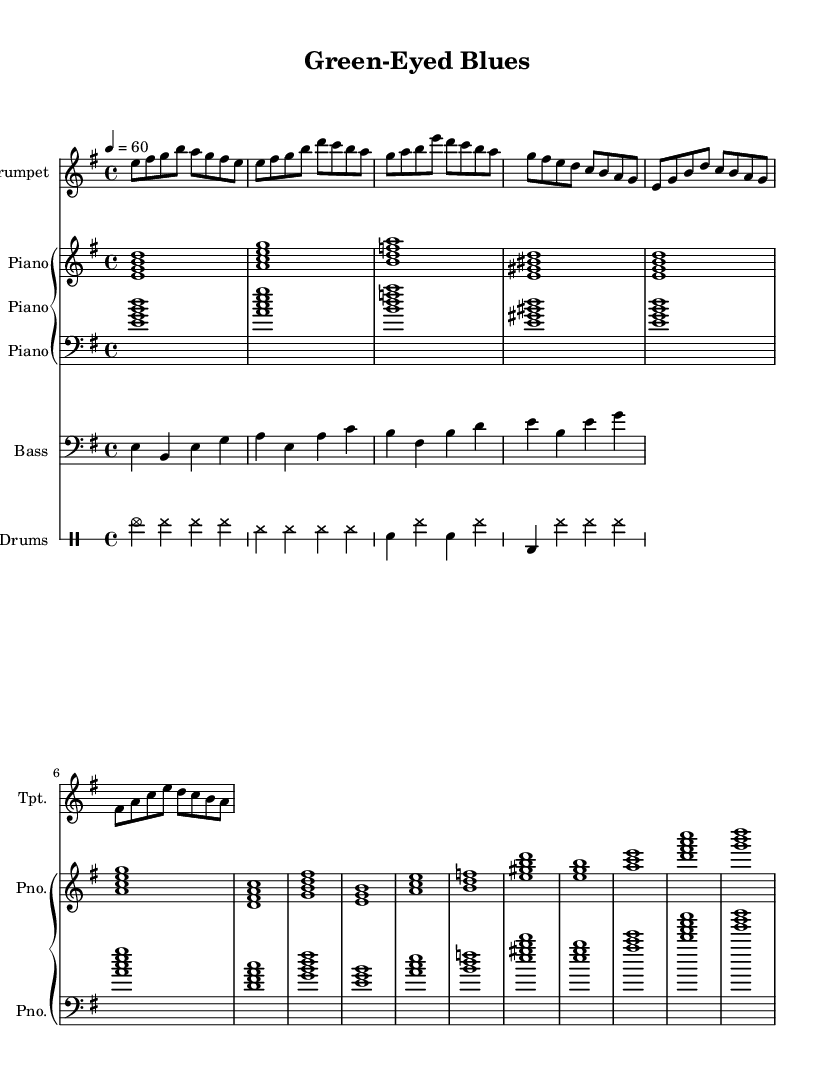What is the key signature of this music? The key signature indicated is E minor, which has one sharp (F#). This can be determined from the initial part of the sheet music where E minor is explicitly stated.
Answer: E minor What is the time signature of this music? The time signature shown in the sheet music is 4/4, which is specified at the beginning of the score. This means there are four beats per measure, and each beat is a quarter note.
Answer: 4/4 What is the tempo marking of this music? The tempo marking is set to 60 beats per minute, as noted in the tempo indication at the start of the score. This indicates a slow pace suitable for smooth jazz.
Answer: 60 Which instruments are included in this piece? The instruments listed are Trumpet, Piano, Bass, and Drums. This is evident from the staff headings in the score that label each instrument accordingly.
Answer: Trumpet, Piano, Bass, Drums What chord follows the E minor seventh chord in the progression? The chord progression shows that after the E minor seventh chord, the next chord is A minor seventh, which can be confirmed by looking at the chord symbols in the chord mode.
Answer: A minor seventh How many measures are in the verse section? The verse section consists of 4 measures, as counted from the music notation provided for the verse. Each measure is clearly delineated, making it easy to count.
Answer: 4 What is the mood of this jazz piece based on its title? The title "Green-Eyed Blues" suggests a mood of ambition and envy, reflecting the emotional themes often explored in smooth jazz. The title is indicative of the overall tone set by the music.
Answer: Ambition and envy 